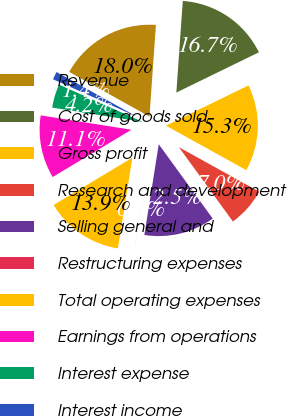Convert chart to OTSL. <chart><loc_0><loc_0><loc_500><loc_500><pie_chart><fcel>Revenue<fcel>Cost of goods sold<fcel>Gross profit<fcel>Research and development<fcel>Selling general and<fcel>Restructuring expenses<fcel>Total operating expenses<fcel>Earnings from operations<fcel>Interest expense<fcel>Interest income<nl><fcel>18.04%<fcel>16.66%<fcel>15.27%<fcel>6.95%<fcel>12.5%<fcel>0.01%<fcel>13.88%<fcel>11.11%<fcel>4.17%<fcel>1.4%<nl></chart> 